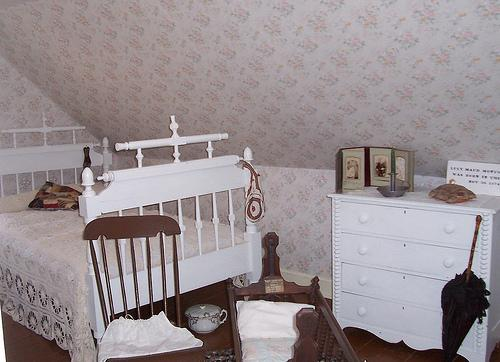How many distinct objects are mentioned in the image description? 15 distinct objects are mentioned in the image description. Identify the primary furniture pieces in the image. A cloth drawer, a chair, a bed, and a rocking baby bed are the primary furniture pieces in the image. Count the number of objects mentioned that are on the floor or under the bed. Three objects are on the floor or under the bed: the pot, wooden rocking baby bed, and a lace table cloth. Describe the design of the wallpaper on the wall. The wallpaper on the wall has a floral pattern. What is the umbrella leaning on, and what color is it? The umbrella is leaning on the dresser, and it is black in color. Provide a brief overview of the scene depicted in the image. The image is a bedroom scene with various white furniture pieces including a bed, dresser, and drawer. There is a wooden chair and rocking baby bed, a black umbrella, a white pot, and floral wallpaper on the wall. Evaluate the overall sentiment of the image. The overall sentiment of the image suggests a cozy, comfortable, and peaceful atmosphere, with soft colors and wooden textures in a bedroom setting. List the objects mentioned in the image that have the color white. Drawer, bed frame, knob on the drawer, trim along the bottom of the wall, dresser, pot, bedspread, chest of drawers, wooden framed bed, and a pot with a lid are white. What is the dominant color of the drawer and the bed? The drawer and the bed are both white in color. Analyze the material of the bed and the chair. The bed is wooden and the chair is made out of wood as well. Describe the white pot in the image. It is a white tea pot with a lid. Is there an object with a wooden frame in the image? If yes, what is it? Yes, a wooden rocking baby bed. What is the color and material of the chair in the image? The chair is brown and made out of wood. What is the object under the bed? A pot Identify an object on the floor and its color. A pot, white in color. Describe the umbrella in the scene. A black umbrella leaning on the dresser with a wooden handle. Describe the state of the dresser drawer. The drawer is closed. Which object in the image has an old-fashioned appearance? Picture frame on top of the dresser What is the design on the wall? Floral wallpaper What is the color of the bedspread on the bed? White What kind of flooring is present in the room? Dark hardwood floors What material is the bed frame made of? Wood What is the object on the dresser with a silver appearance? A silver candleholder Identify the object with a sloped structure in the image. Ceiling of the room What type of room is depicted in the image? A bedroom What is the object laying on top of the bed? A white cloth Which object has a floral pattern on it? Wallpaper on the wall Describe the closed cloth drawer. The cloth drawer is white, closed, and has a white knob. 